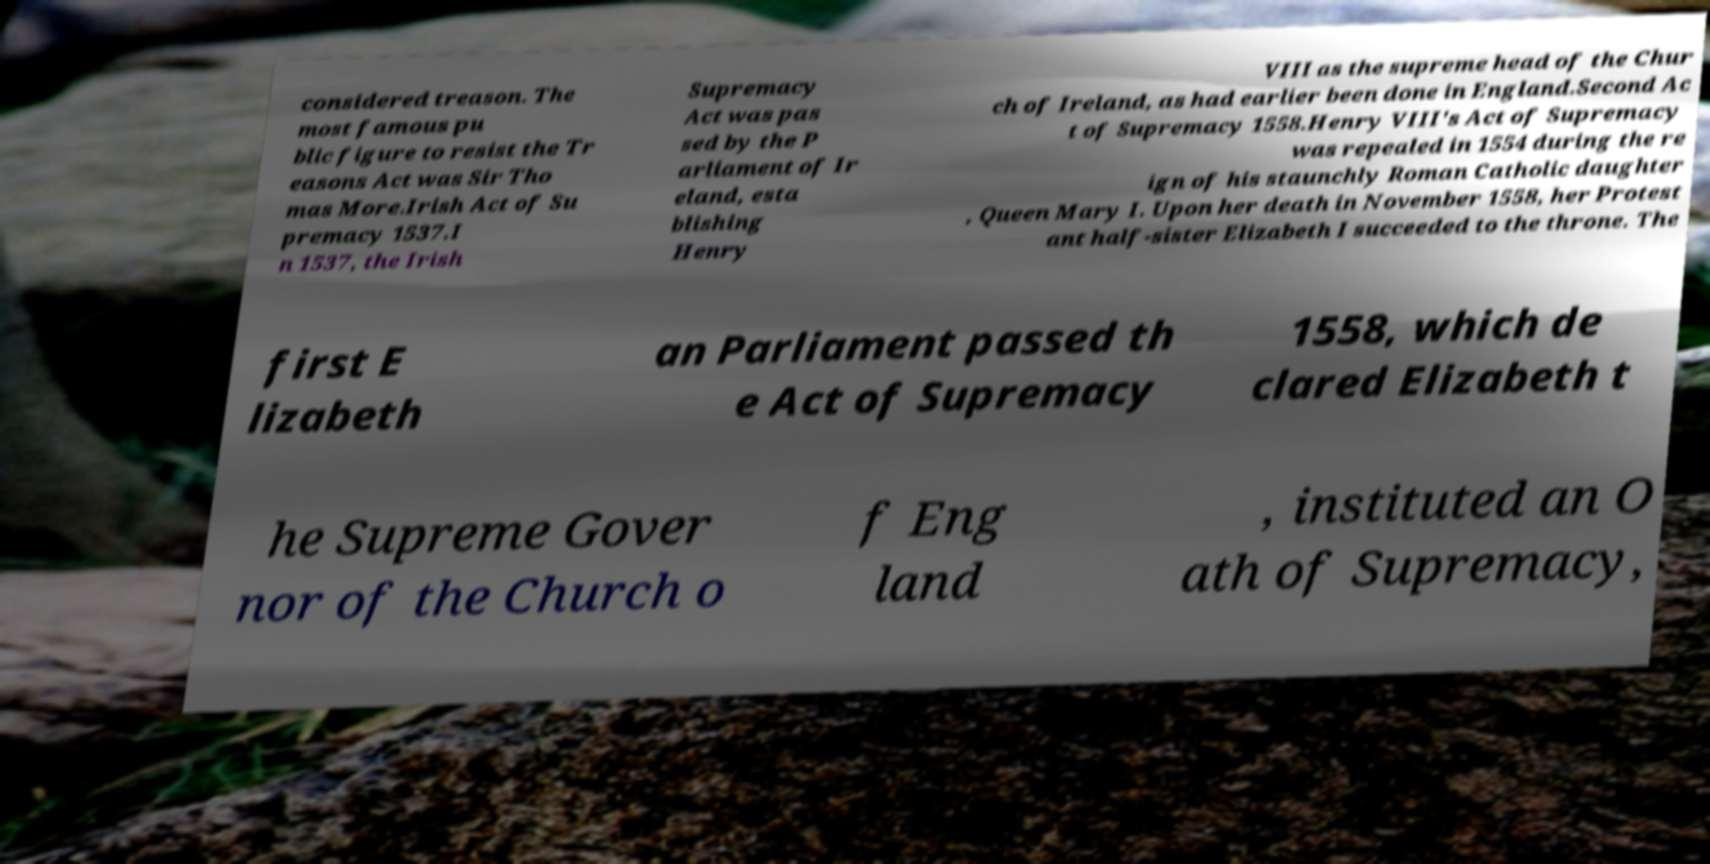I need the written content from this picture converted into text. Can you do that? considered treason. The most famous pu blic figure to resist the Tr easons Act was Sir Tho mas More.Irish Act of Su premacy 1537.I n 1537, the Irish Supremacy Act was pas sed by the P arliament of Ir eland, esta blishing Henry VIII as the supreme head of the Chur ch of Ireland, as had earlier been done in England.Second Ac t of Supremacy 1558.Henry VIII's Act of Supremacy was repealed in 1554 during the re ign of his staunchly Roman Catholic daughter , Queen Mary I. Upon her death in November 1558, her Protest ant half-sister Elizabeth I succeeded to the throne. The first E lizabeth an Parliament passed th e Act of Supremacy 1558, which de clared Elizabeth t he Supreme Gover nor of the Church o f Eng land , instituted an O ath of Supremacy, 